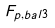Convert formula to latex. <formula><loc_0><loc_0><loc_500><loc_500>F _ { p , { b a l } 3 }</formula> 